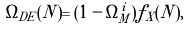<formula> <loc_0><loc_0><loc_500><loc_500>\Omega _ { D E } ( N ) = ( 1 - \Omega _ { M } ^ { i } ) f _ { X } ( N ) ,</formula> 